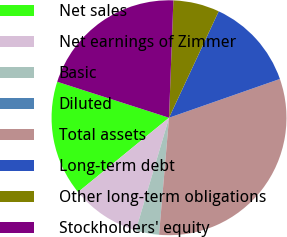Convert chart to OTSL. <chart><loc_0><loc_0><loc_500><loc_500><pie_chart><fcel>Net sales<fcel>Net earnings of Zimmer<fcel>Basic<fcel>Diluted<fcel>Total assets<fcel>Long-term debt<fcel>Other long-term obligations<fcel>Stockholders' equity<nl><fcel>15.87%<fcel>9.53%<fcel>3.19%<fcel>0.02%<fcel>31.72%<fcel>12.7%<fcel>6.36%<fcel>20.64%<nl></chart> 